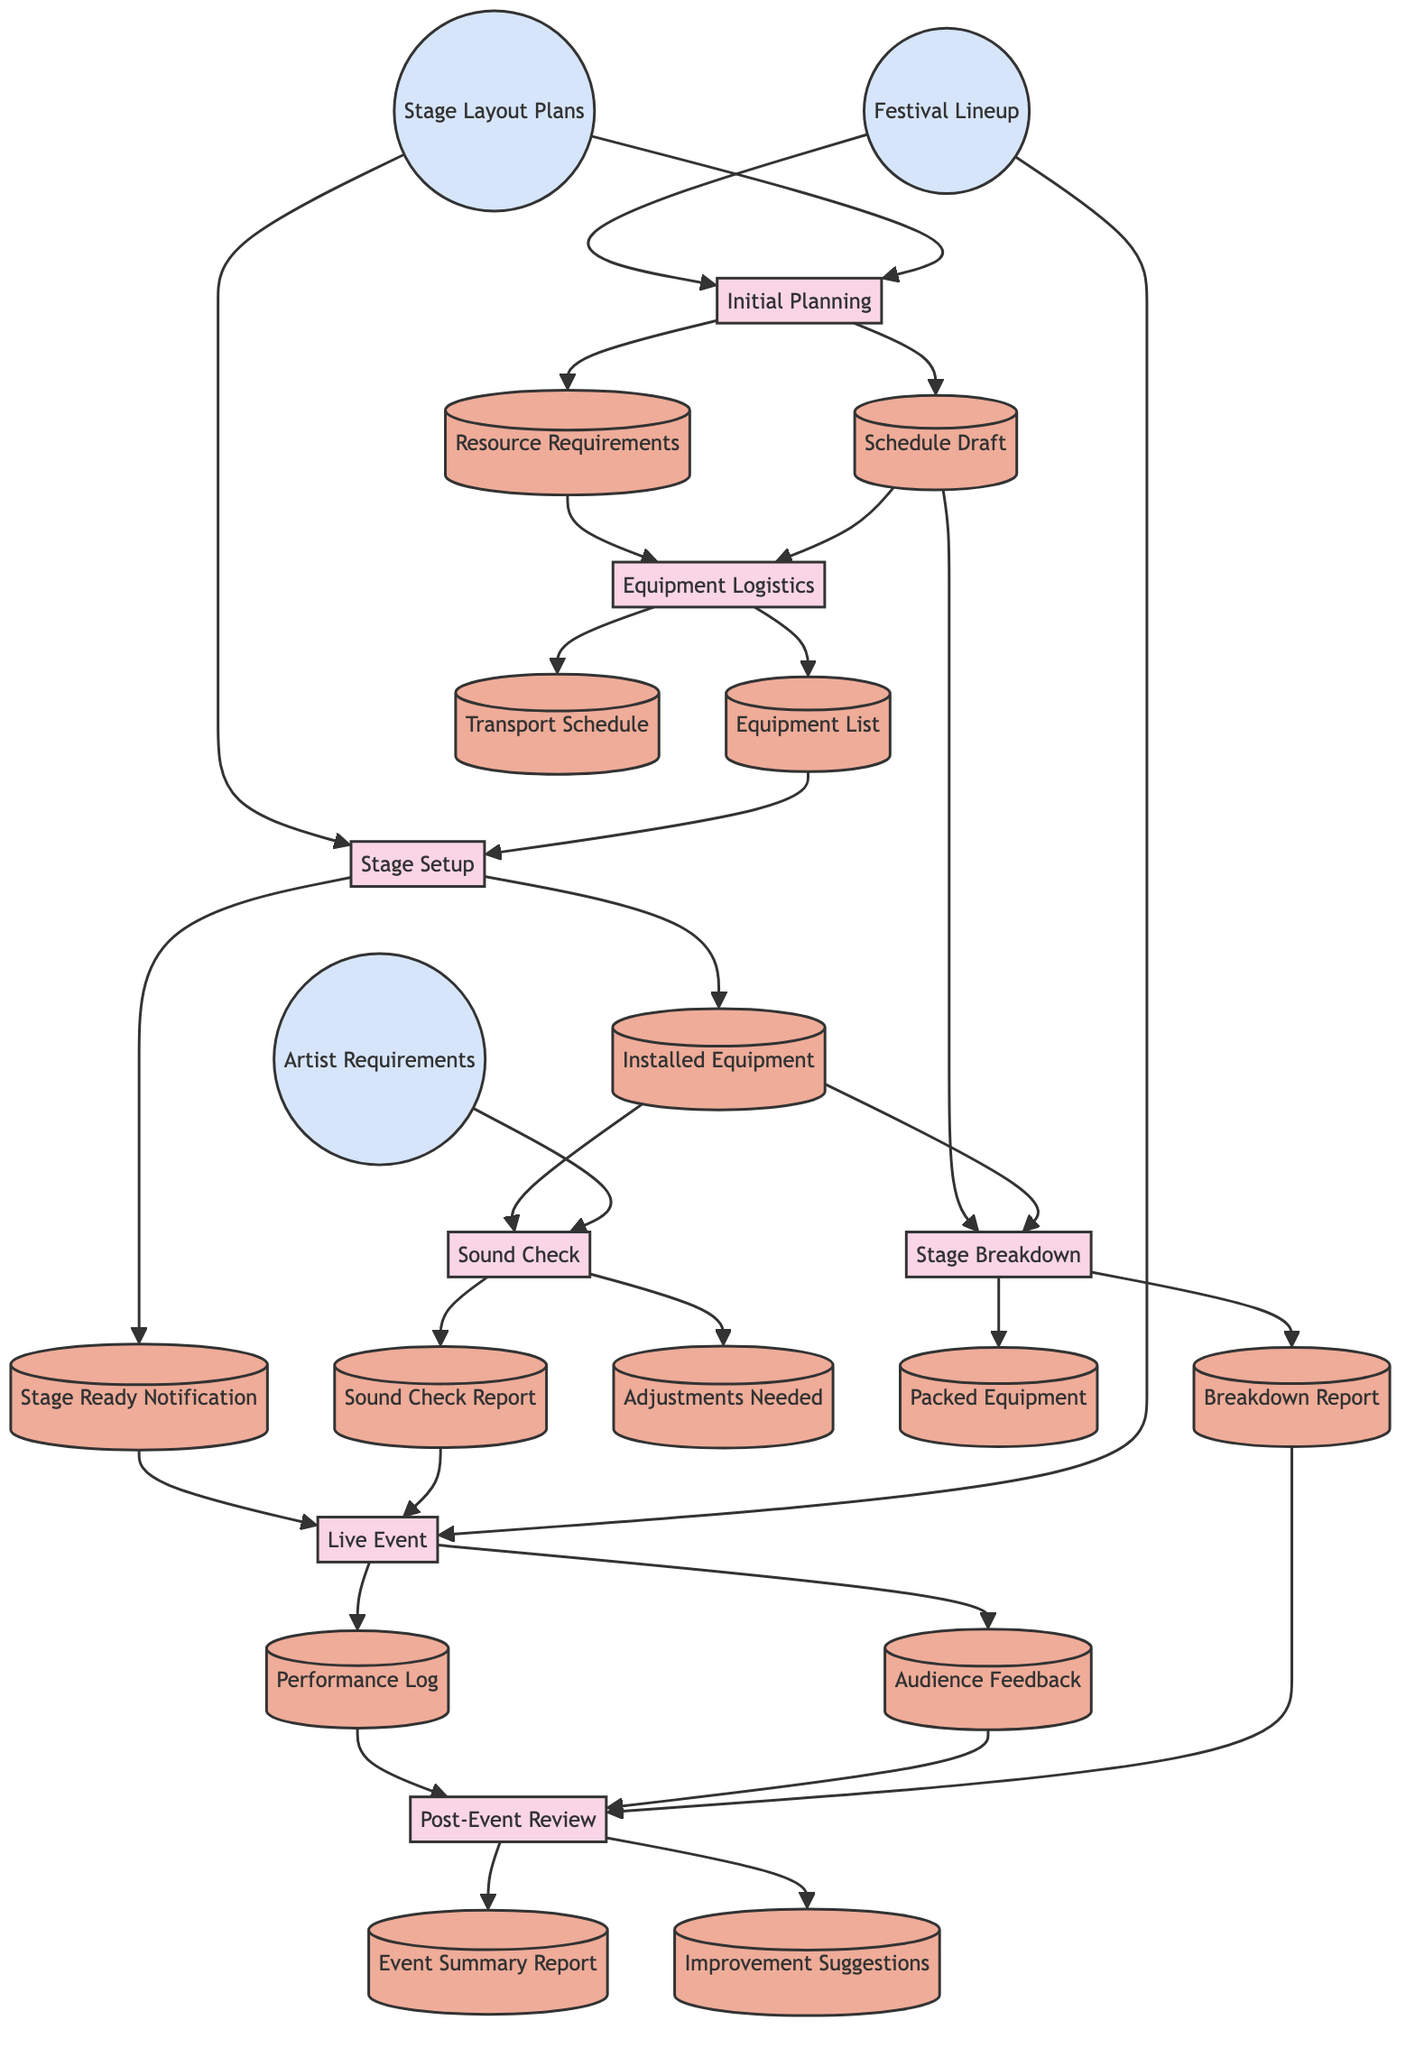What is the input for the Sound Check process? The inputs for the Sound Check process are the Installed Equipment and Artist Requirements, which is specified in the diagram.
Answer: Installed Equipment, Artist Requirements How many outputs does the Live Event process produce? The Live Event process has two outputs: Performance Log and Audience Feedback, as shown in the diagram.
Answer: 2 What is the first process in the workflow? The first process listed in the diagram is Initial Planning, which is at the start of the flow.
Answer: Initial Planning Which process uses the output of Equipment Logistics? The process that uses the output of Equipment Logistics, specifically the Equipment List, is the Stage Setup, as indicated in the flow.
Answer: Stage Setup What inputs does the Stage Breakdown process require? The inputs required for the Stage Breakdown process are Schedule Draft and Installed Equipment, which are connected to this process in the diagram.
Answer: Schedule Draft, Installed Equipment What is the last process in the workflow? The last process in the workflow is Post-Event Review, which is linked to the various outputs from the previous processes and represents the conclusion.
Answer: Post-Event Review Which two processes produce a report as an output? The two processes that produce a report as an output are Sound Check (Sound Check Report) and Stage Breakdown (Breakdown Report), as detailed in the workflow.
Answer: Sound Check, Stage Breakdown How does the Post-Event Review process receive its inputs? The Post-Event Review process receives its inputs from three specific outputs: Performance Log, Audience Feedback, and Breakdown Report, showing the data flow to this process.
Answer: From Performance Log, Audience Feedback, Breakdown Report What do the Resource Requirements connect to? The Resource Requirements output connects to Equipment Logistics, indicating that it provides necessary information for this subsequent process in the diagram.
Answer: Equipment Logistics 